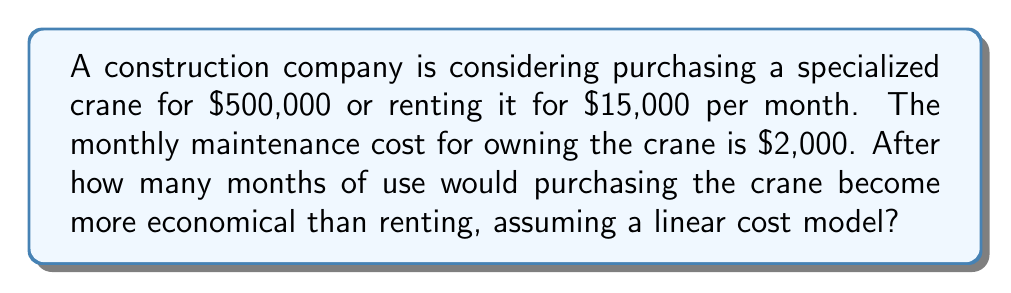Can you answer this question? Let's approach this step-by-step:

1) Define variables:
   Let $x$ = number of months

2) Set up equations:
   Cost of purchasing: $500,000 + 2,000x$
   Cost of renting: $15,000x$

3) Find the break-even point by equating these costs:
   $$500,000 + 2,000x = 15,000x$$

4) Solve the equation:
   $$500,000 = 15,000x - 2,000x$$
   $$500,000 = 13,000x$$

5) Divide both sides by 13,000:
   $$\frac{500,000}{13,000} = x$$

6) Calculate:
   $$x \approx 38.46$$

7) Since we can't have a fractional month in this context, we round up to the next whole number.

Therefore, purchasing becomes more economical after 39 months of use.
Answer: 39 months 